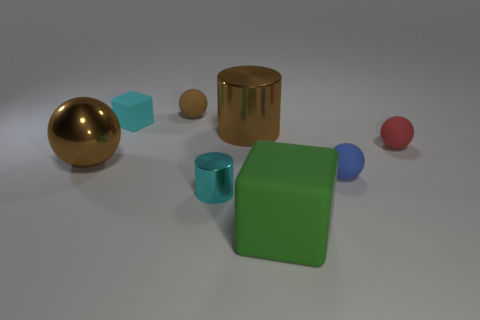What is the size of the blue sphere?
Make the answer very short. Small. Are the cube on the left side of the large green matte cube and the small ball that is in front of the shiny ball made of the same material?
Provide a succinct answer. Yes. Is there a small shiny cylinder that has the same color as the big rubber block?
Give a very brief answer. No. The rubber cube that is the same size as the brown rubber sphere is what color?
Offer a terse response. Cyan. There is a cylinder that is in front of the big brown ball; does it have the same color as the big matte thing?
Your answer should be very brief. No. Is there a cylinder made of the same material as the green thing?
Keep it short and to the point. No. There is a big object that is the same color as the big sphere; what is its shape?
Your answer should be very brief. Cylinder. Is the number of tiny cyan cylinders to the right of the tiny blue matte sphere less than the number of yellow rubber cylinders?
Your response must be concise. No. Does the rubber cube behind the shiny ball have the same size as the blue matte thing?
Offer a terse response. Yes. How many big shiny objects are the same shape as the tiny cyan metallic object?
Provide a succinct answer. 1. 